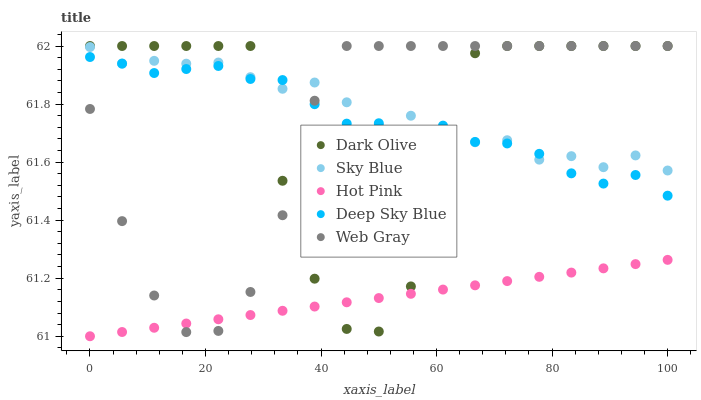Does Hot Pink have the minimum area under the curve?
Answer yes or no. Yes. Does Sky Blue have the maximum area under the curve?
Answer yes or no. Yes. Does Dark Olive have the minimum area under the curve?
Answer yes or no. No. Does Dark Olive have the maximum area under the curve?
Answer yes or no. No. Is Hot Pink the smoothest?
Answer yes or no. Yes. Is Dark Olive the roughest?
Answer yes or no. Yes. Is Web Gray the smoothest?
Answer yes or no. No. Is Web Gray the roughest?
Answer yes or no. No. Does Hot Pink have the lowest value?
Answer yes or no. Yes. Does Dark Olive have the lowest value?
Answer yes or no. No. Does Web Gray have the highest value?
Answer yes or no. Yes. Does Deep Sky Blue have the highest value?
Answer yes or no. No. Is Hot Pink less than Sky Blue?
Answer yes or no. Yes. Is Sky Blue greater than Hot Pink?
Answer yes or no. Yes. Does Deep Sky Blue intersect Dark Olive?
Answer yes or no. Yes. Is Deep Sky Blue less than Dark Olive?
Answer yes or no. No. Is Deep Sky Blue greater than Dark Olive?
Answer yes or no. No. Does Hot Pink intersect Sky Blue?
Answer yes or no. No. 